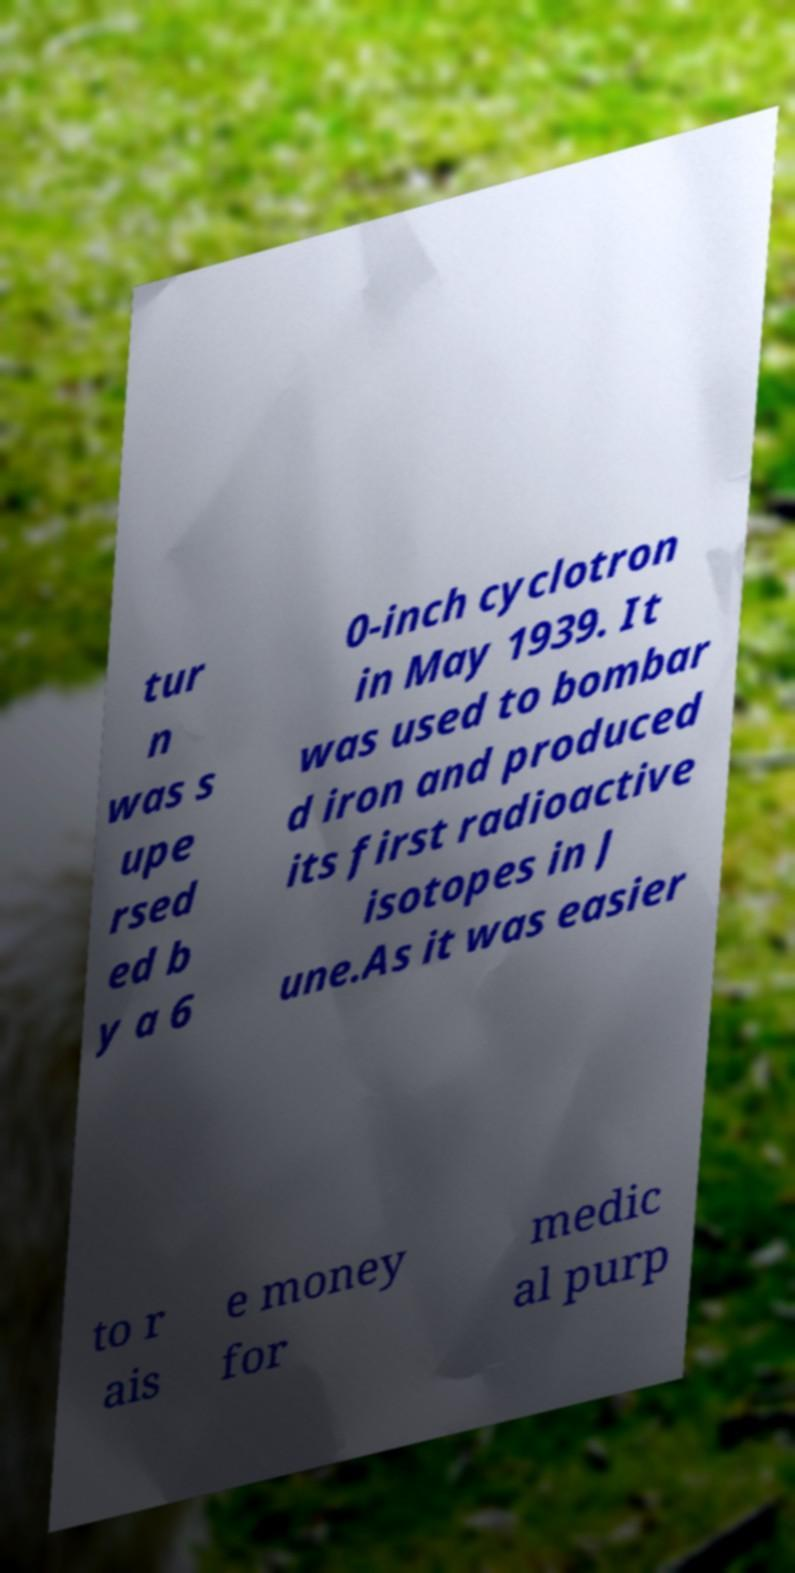Please identify and transcribe the text found in this image. tur n was s upe rsed ed b y a 6 0-inch cyclotron in May 1939. It was used to bombar d iron and produced its first radioactive isotopes in J une.As it was easier to r ais e money for medic al purp 